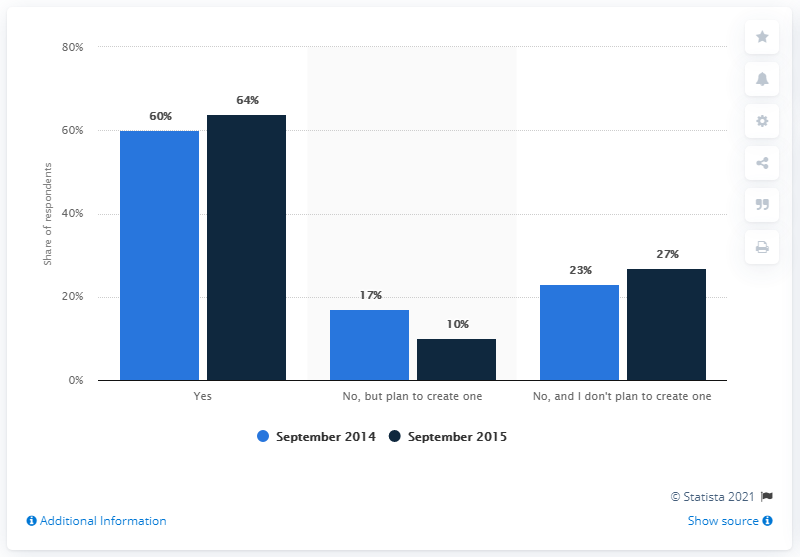Give some essential details in this illustration. On or before September 2015, website ownership among small and medium-sized businesses in the United States was in effect. In September 2014, it was determined that approximately 60% of the responses were "Yes. During the period of September 2014 to September 2015, there was a decrease of 7 percentage points in the percentage of respondents who stated "No, but plan to create one" in their answer to the question "Do you have a personal workspace or do you work in a common area at home?" compared to the previous year. 